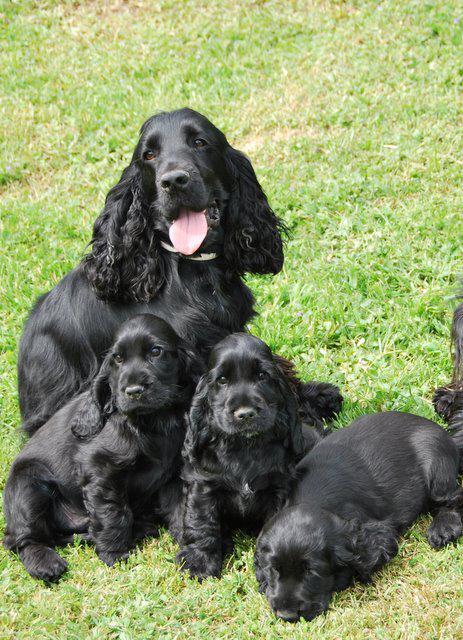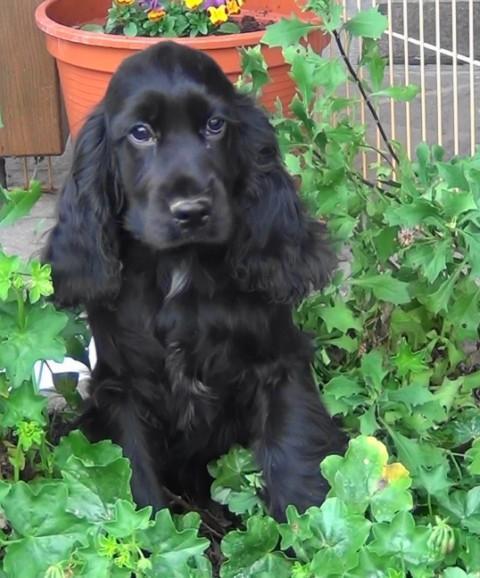The first image is the image on the left, the second image is the image on the right. Assess this claim about the two images: "An all black puppy and an all brown puppy are next to each other.". Correct or not? Answer yes or no. No. The first image is the image on the left, the second image is the image on the right. Evaluate the accuracy of this statement regarding the images: "There is a tan dog beside a black dog in one of the images.". Is it true? Answer yes or no. No. 